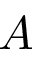Convert formula to latex. <formula><loc_0><loc_0><loc_500><loc_500>A</formula> 